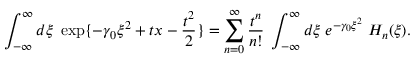Convert formula to latex. <formula><loc_0><loc_0><loc_500><loc_500>\int _ { - \infty } ^ { \infty } d \xi \, \exp \{ - \gamma _ { 0 } \xi ^ { 2 } + t x - { \frac { t ^ { 2 } } { 2 } } \} = \sum _ { n = 0 } ^ { \infty } { \frac { t ^ { n } } { n ! } } \, \int _ { - \infty } ^ { \infty } d \xi \, e ^ { - \gamma _ { 0 } \xi ^ { 2 } } \, H _ { n } ( \xi ) .</formula> 